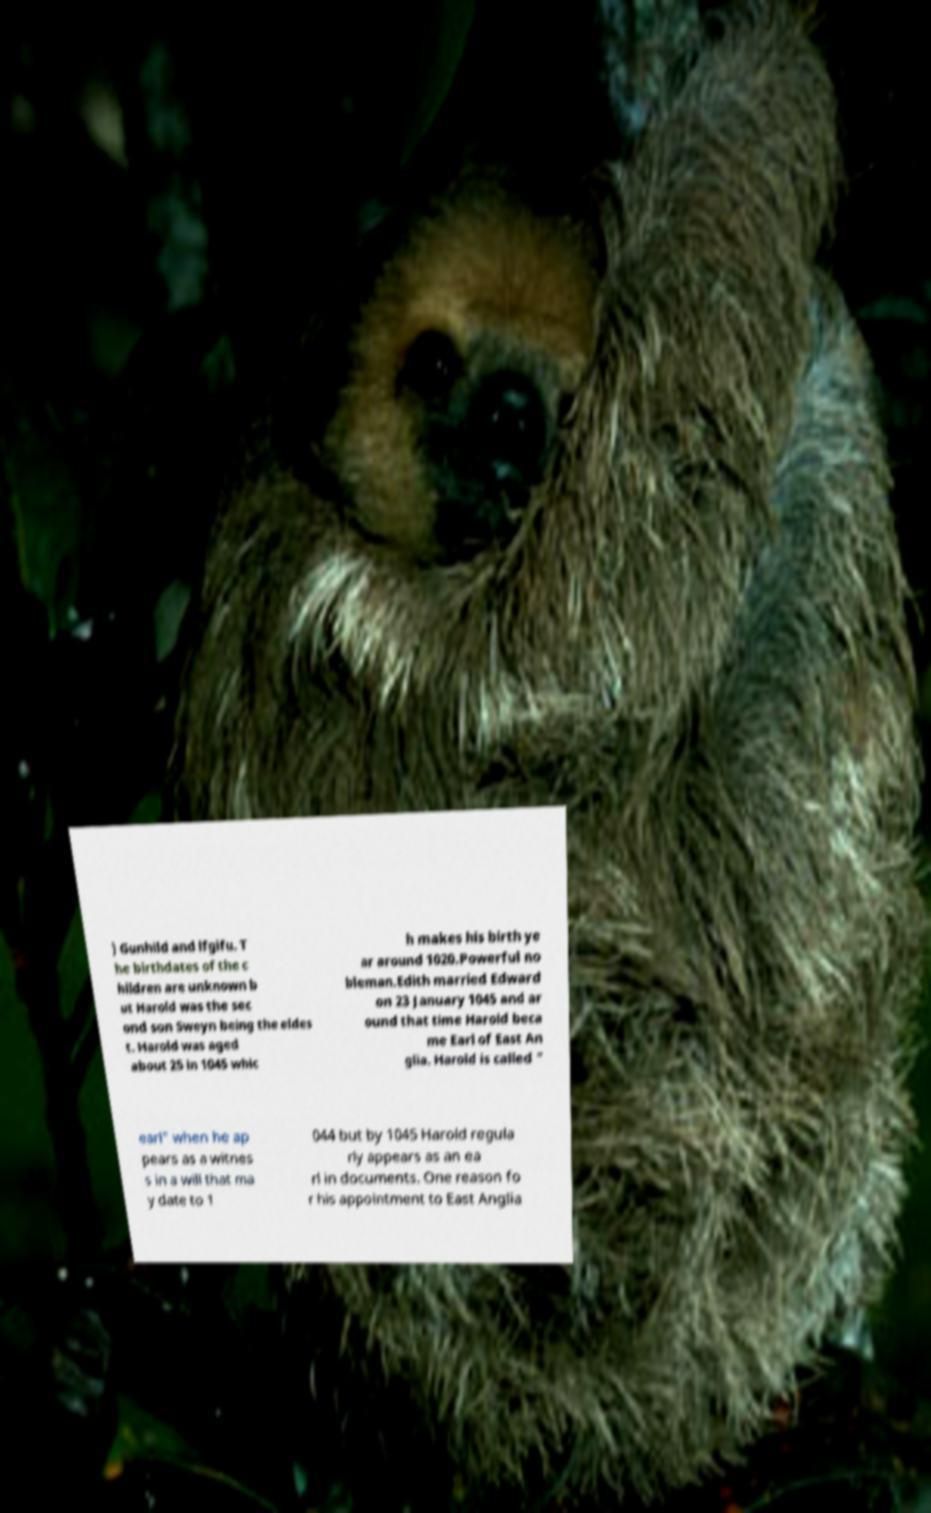For documentation purposes, I need the text within this image transcribed. Could you provide that? ) Gunhild and lfgifu. T he birthdates of the c hildren are unknown b ut Harold was the sec ond son Sweyn being the eldes t. Harold was aged about 25 in 1045 whic h makes his birth ye ar around 1020.Powerful no bleman.Edith married Edward on 23 January 1045 and ar ound that time Harold beca me Earl of East An glia. Harold is called " earl" when he ap pears as a witnes s in a will that ma y date to 1 044 but by 1045 Harold regula rly appears as an ea rl in documents. One reason fo r his appointment to East Anglia 